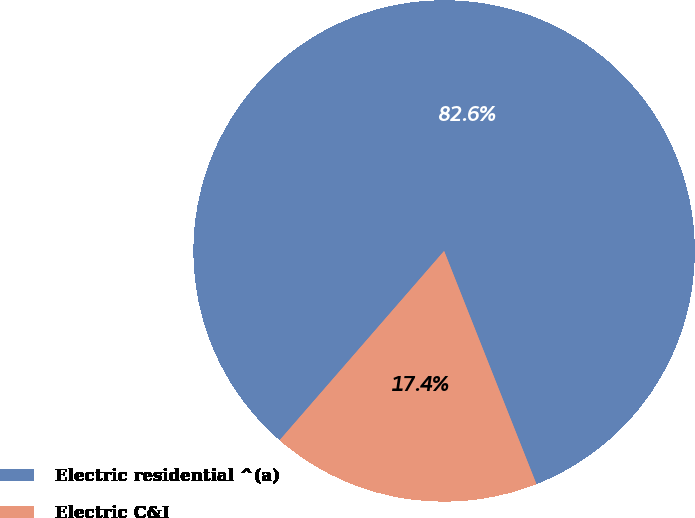Convert chart to OTSL. <chart><loc_0><loc_0><loc_500><loc_500><pie_chart><fcel>Electric residential ^(a)<fcel>Electric C&I<nl><fcel>82.61%<fcel>17.39%<nl></chart> 